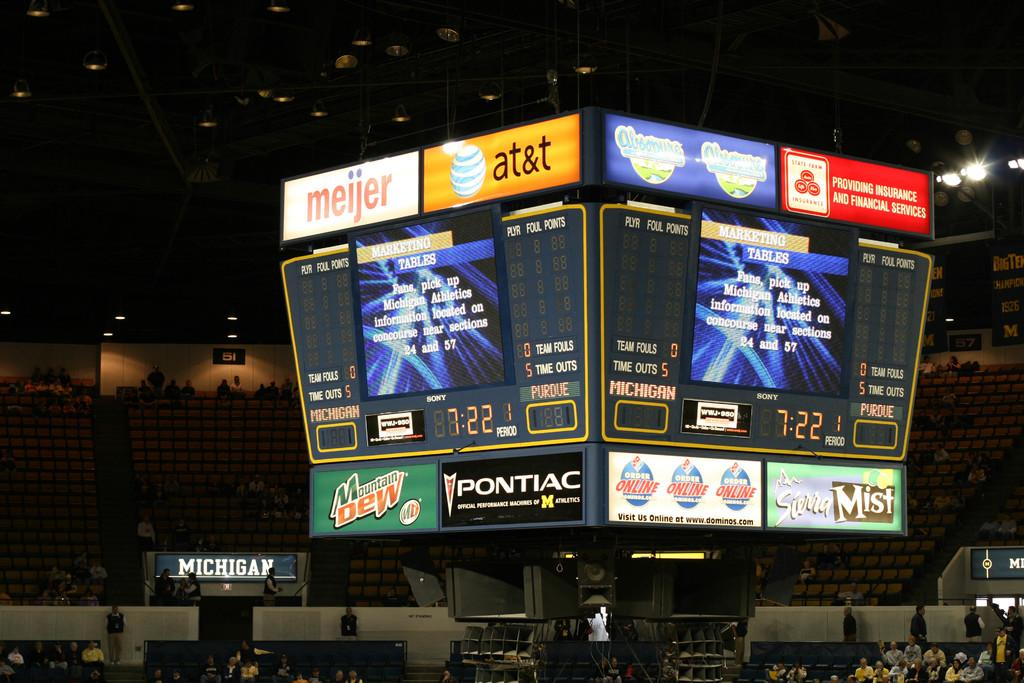<image>
Provide a brief description of the given image. An arena scoreboard includes ads for Pontiac and AT&T. 